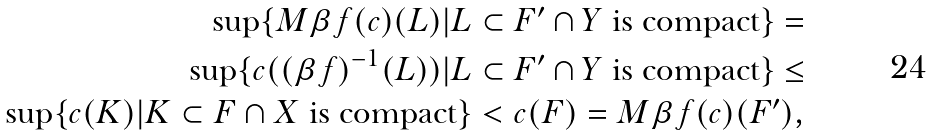<formula> <loc_0><loc_0><loc_500><loc_500>\sup \{ M \beta f ( c ) ( L ) | L \subset F ^ { \prime } \cap Y \text { is compact} \} = \\ \sup \{ c ( ( \beta f ) ^ { - 1 } ( L ) ) | L \subset F ^ { \prime } \cap Y \text { is compact} \} \leq \\ \sup \{ c ( K ) | K \subset F \cap X \text { is compact} \} < c ( F ) = M \beta f ( c ) ( F ^ { \prime } ) ,</formula> 